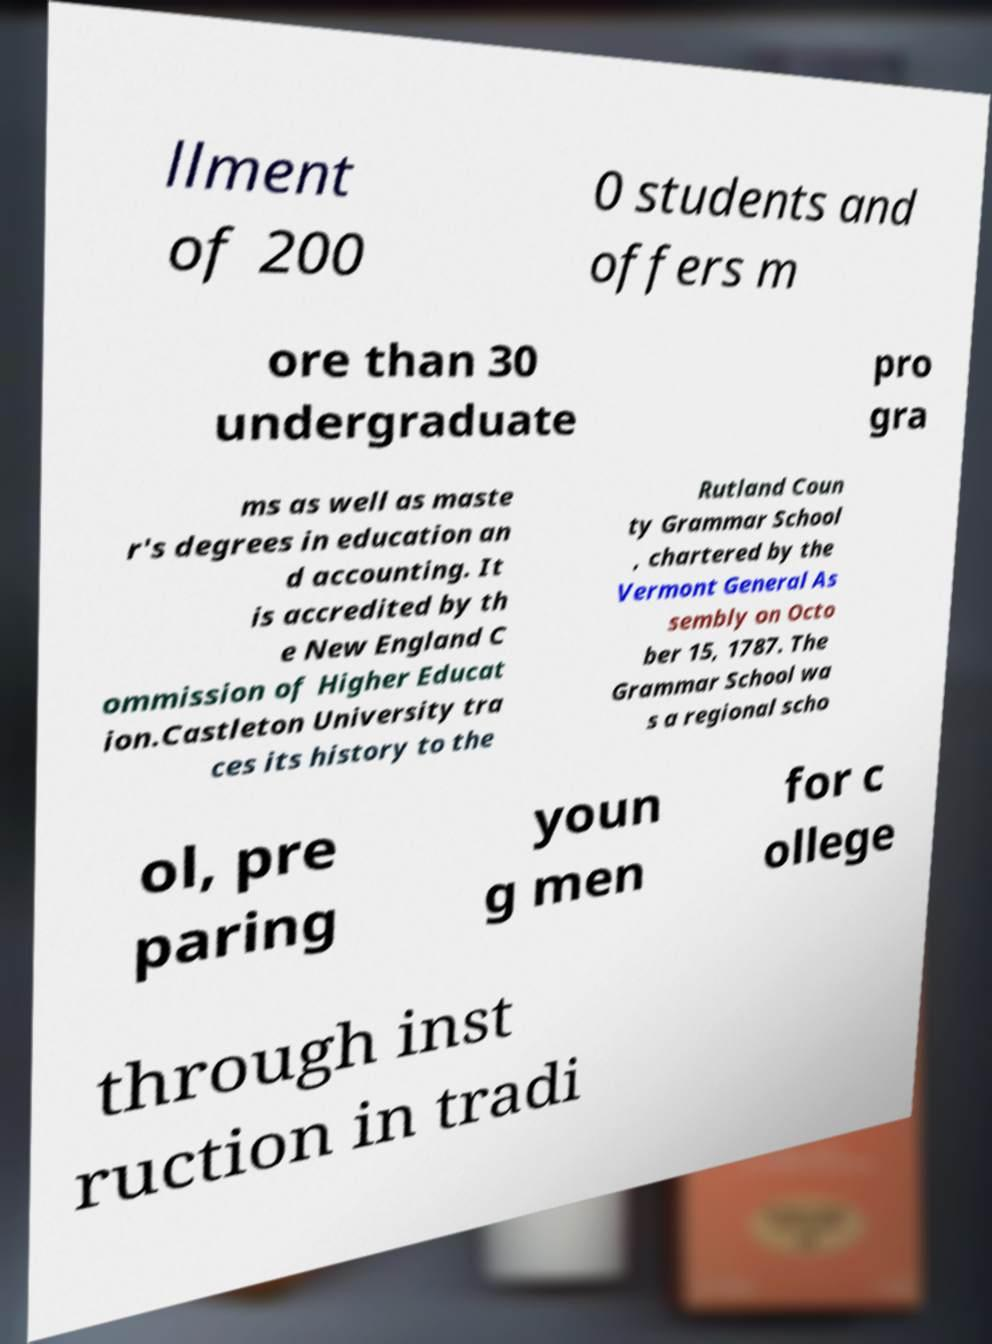What messages or text are displayed in this image? I need them in a readable, typed format. llment of 200 0 students and offers m ore than 30 undergraduate pro gra ms as well as maste r's degrees in education an d accounting. It is accredited by th e New England C ommission of Higher Educat ion.Castleton University tra ces its history to the Rutland Coun ty Grammar School , chartered by the Vermont General As sembly on Octo ber 15, 1787. The Grammar School wa s a regional scho ol, pre paring youn g men for c ollege through inst ruction in tradi 